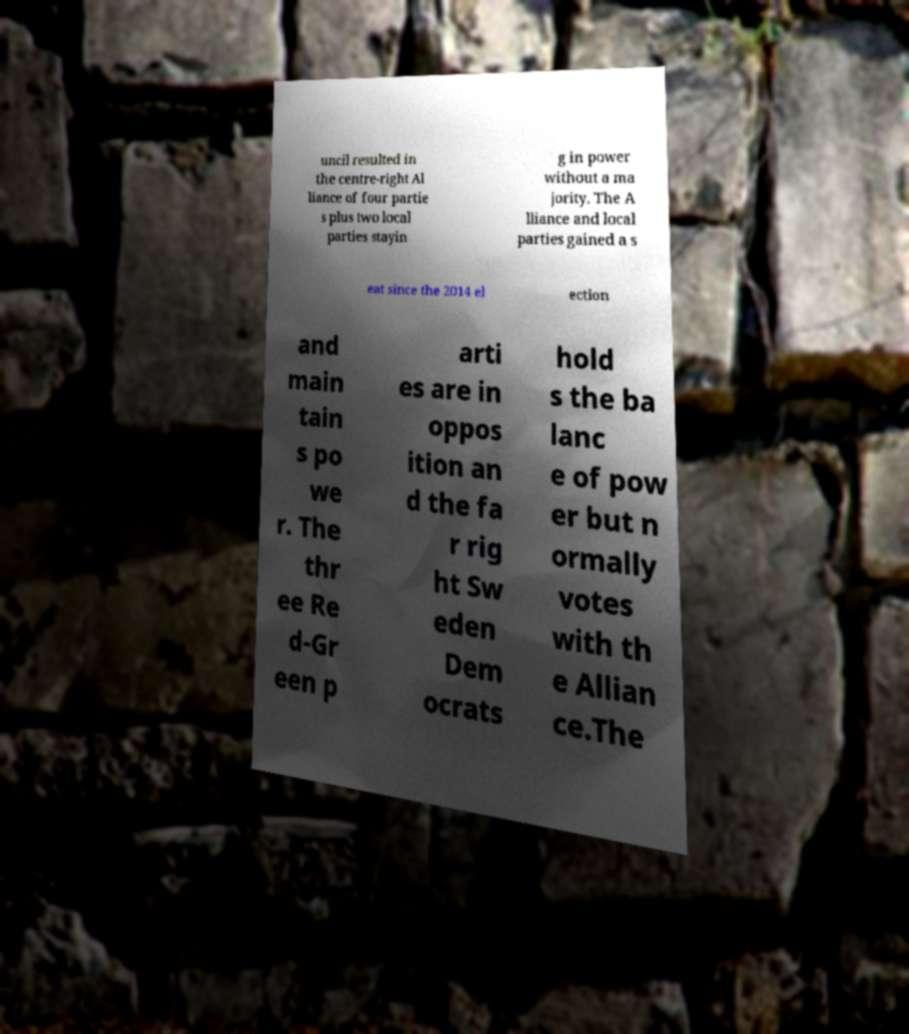There's text embedded in this image that I need extracted. Can you transcribe it verbatim? uncil resulted in the centre-right Al liance of four partie s plus two local parties stayin g in power without a ma jority. The A lliance and local parties gained a s eat since the 2014 el ection and main tain s po we r. The thr ee Re d-Gr een p arti es are in oppos ition an d the fa r rig ht Sw eden Dem ocrats hold s the ba lanc e of pow er but n ormally votes with th e Allian ce.The 